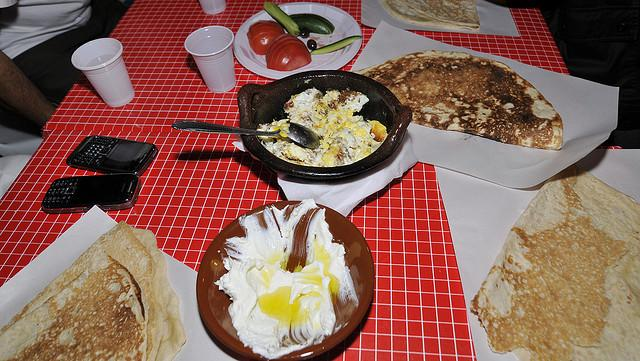This meal is likely for how many people? two 